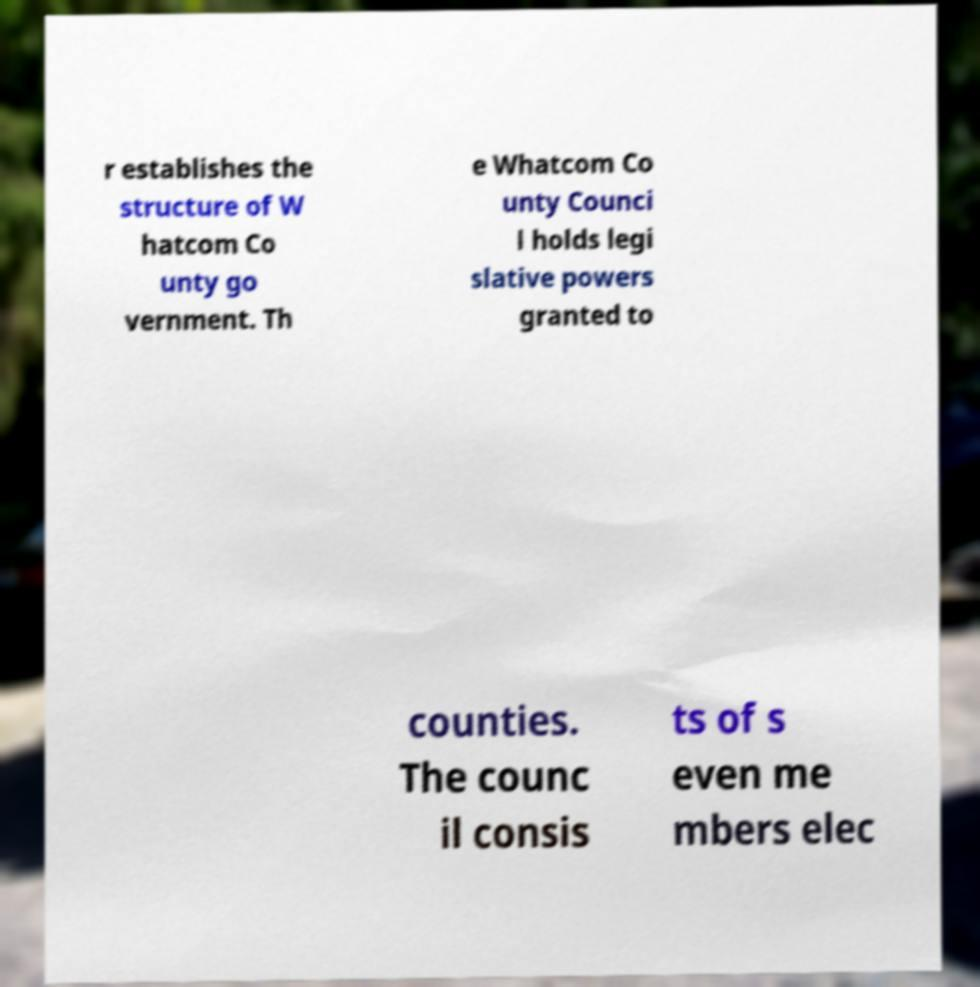There's text embedded in this image that I need extracted. Can you transcribe it verbatim? r establishes the structure of W hatcom Co unty go vernment. Th e Whatcom Co unty Counci l holds legi slative powers granted to counties. The counc il consis ts of s even me mbers elec 